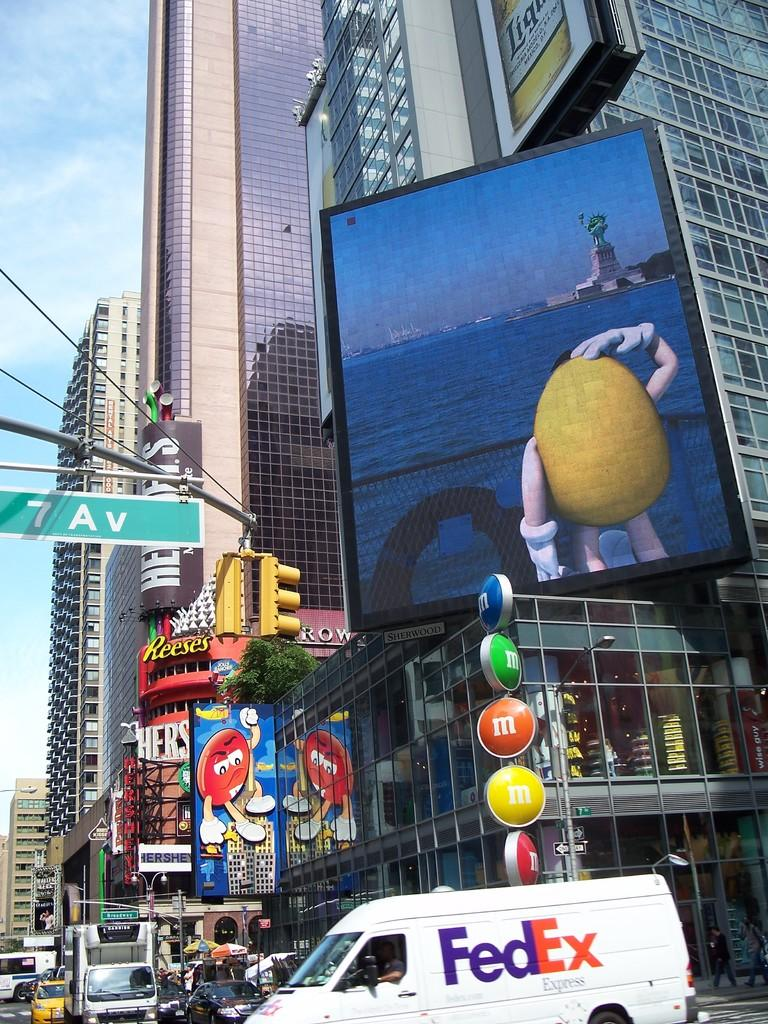Provide a one-sentence caption for the provided image. Fedex van is riding in the streets near a m&m sign and street sign. 